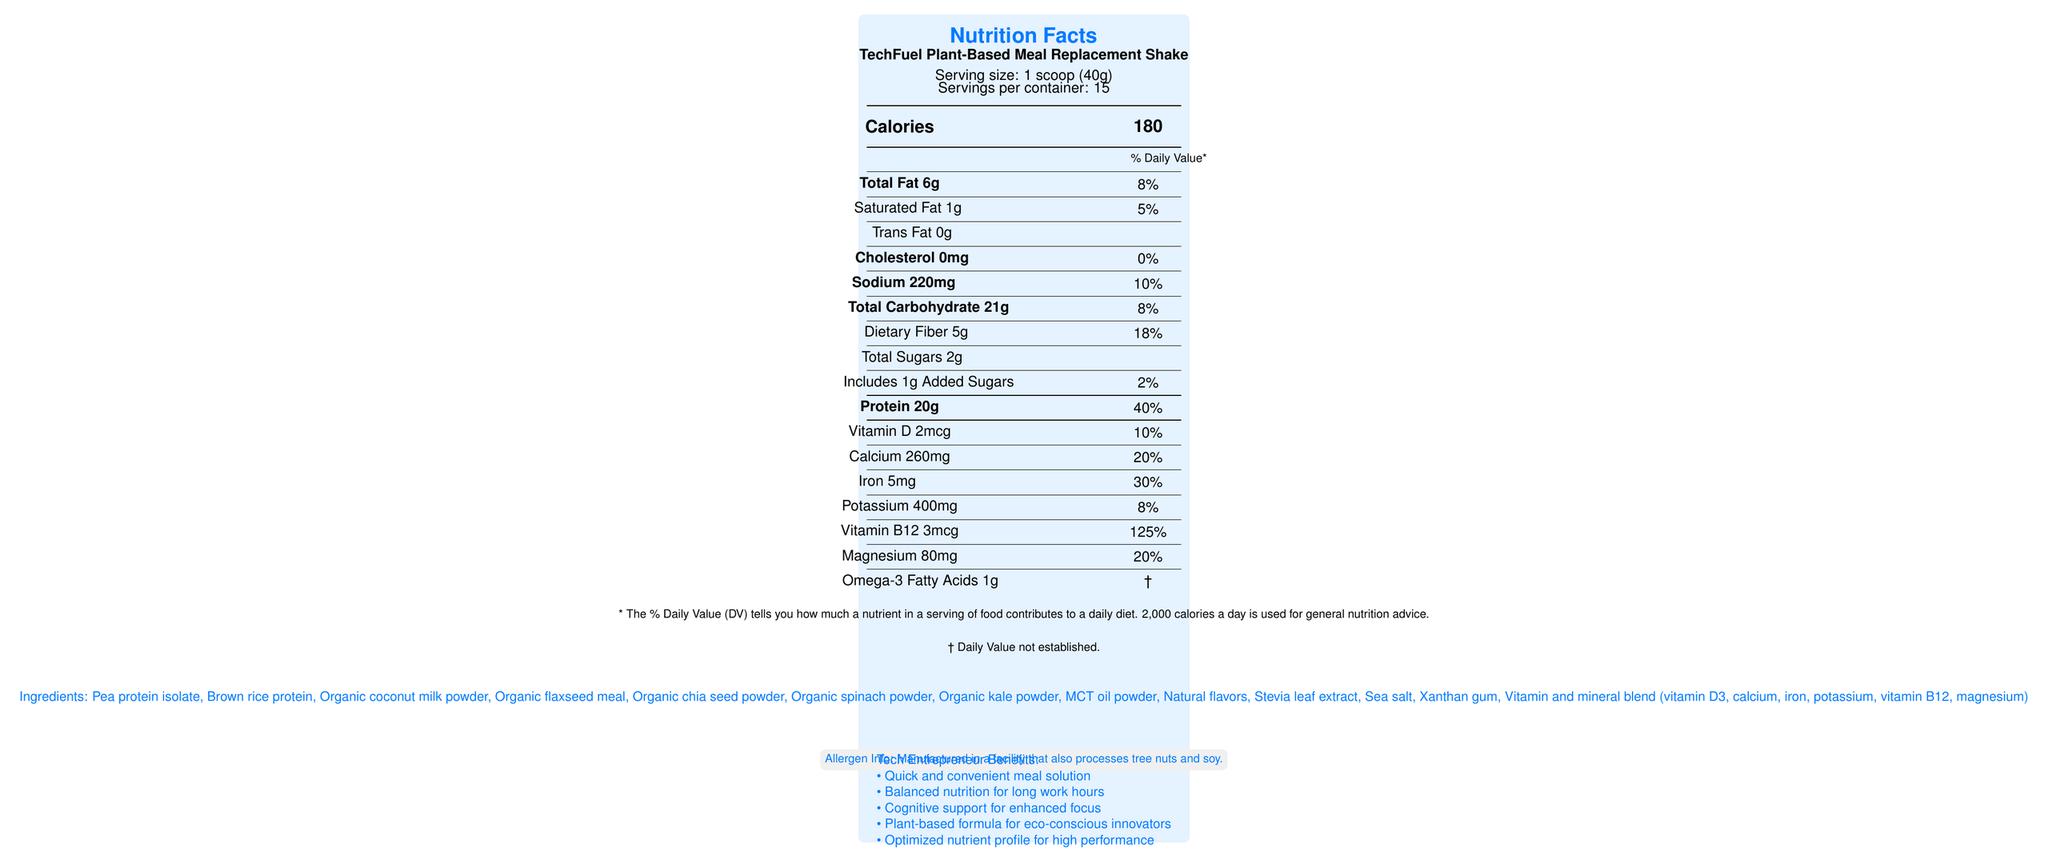How many grams of protein does one serving of the TechFuel Plant-Based Meal Replacement Shake contain? The document specifies that one serving contains 20g of protein.
Answer: 20g What is the percentage of the daily value of dietary fiber per serving? The document states that dietary fiber makes up 18% of the daily value per serving.
Answer: 18% How many servings are there per container? According to the document, each container contains 15 servings.
Answer: 15 What ingredients are listed in the TechFuel Plant-Based Meal Replacement Shake? The document lists these ingredients under the ingredients section.
Answer: Pea protein isolate, Brown rice protein, Organic coconut milk powder, Organic flaxseed meal, Organic chia seed powder, Organic spinach powder, Organic kale powder, MCT oil powder, Natural flavors, Stevia leaf extract, Sea salt, Xanthan gum, Vitamin and mineral blend (vitamin D3, calcium, iron, potassium, vitamin B12, magnesium) What percentage of the daily value of vitamin B12 does one serving provide? The document shows that vitamin B12 in one serving provides 125% of the daily value.
Answer: 125% How many calories are there per serving? The document lists 180 calories per serving.
Answer: 180 Which of the following is not an ingredient in the shake? A. Organic kale powder B. Organic spinach powder C. Almond milk powder D. Brown rice protein The list of ingredients does not include almond milk powder.
Answer: C Which nutrient has the highest percentage of daily value in one serving? A. Magnesium B. Vitamin D C. Vitamin B12 D. Iron Vitamin B12 has a daily value of 125%, which is the highest compared to other nutrients listed.
Answer: C Are there any trans fats in the TechFuel Plant-Based Meal Replacement Shake? The document states that there are 0g of trans fat.
Answer: No Describe the main benefits of the TechFuel Plant-Based Meal Replacement Shake for tech entrepreneurs. The document highlights several benefits tailored to tech entrepreneurs including convenience, balanced nutrition, cognitive support, an eco-friendly formula, and an optimized nutrient profile.
Answer: The shake offers a quick, convenient meal solution with balanced nutrition to support long work hours. It supports cognitive function and focus, is environmentally conscious with a plant-based formula, and is optimized for high-performance individuals. Does the meal replacement shake contain any added sugars? The document indicates that there is 1g of added sugars, which is 2% of the daily value.
Answer: Yes Is it clear from the document where the product is manufactured? The document mentions allergen info, which says it is manufactured in a facility that processes tree nuts and soy, but it does not specify the location of the manufacturing.
Answer: No, not enough information 